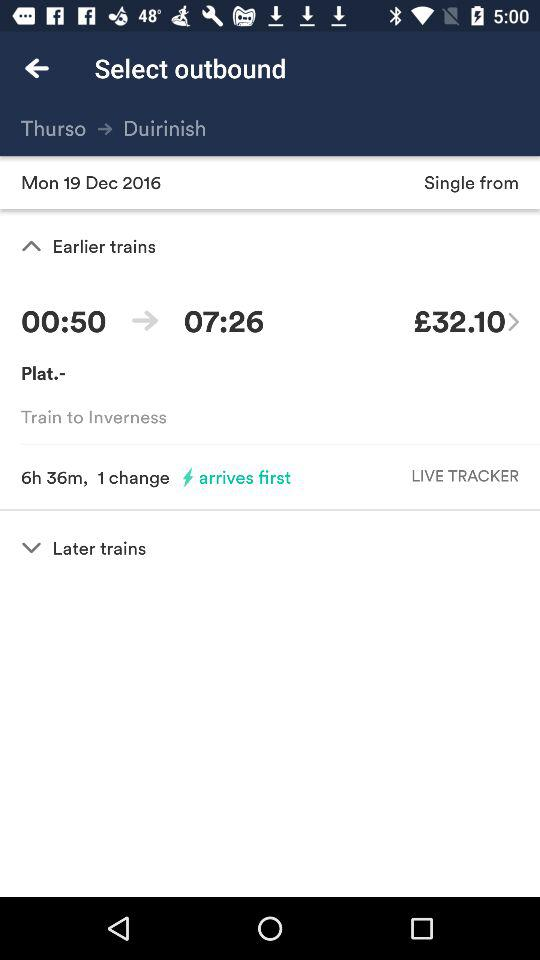How many hours is the total journey time?
Answer the question using a single word or phrase. 6h 36m 